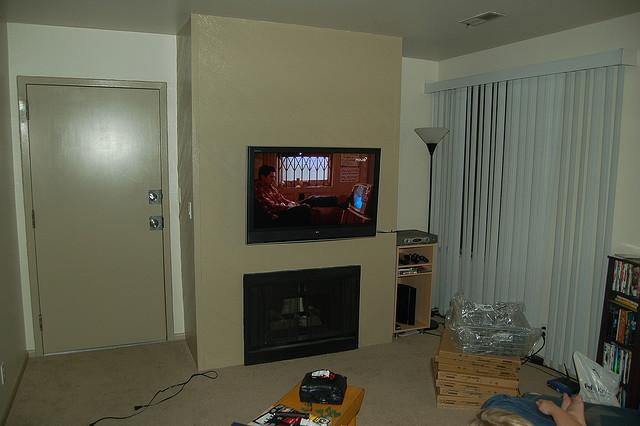What is displayed on the TV screen?
Short answer required. Show. What material is the floor made of?
Answer briefly. Carpet. How many pieces of technology are in the picture?
Quick response, please. 3. How many squares are on the carpet?
Answer briefly. 1. Is this room filled with lots of furniture?
Be succinct. No. Which room is this?
Be succinct. Living room. Is the TV mounted or on a stand?
Write a very short answer. Mounted. What room is this?
Short answer required. Living room. What is on the TV?
Be succinct. Movie. Where is the pink light eliminating from?
Write a very short answer. Tv. Is it sunny outside?
Concise answer only. No. What is on the floor next to the wall with the windows?
Keep it brief. Boxes. What kind of blinds cover the window?
Give a very brief answer. Vertical. Does the door handle turn?
Give a very brief answer. Yes. Is there a calendar on the wall?
Keep it brief. No. What is inside the box?
Answer briefly. Pizza. Is James Dean in the room?
Write a very short answer. No. Is that a flat screen TV?
Concise answer only. Yes. Is the tv on?
Short answer required. Yes. Does this room appear clean?
Quick response, please. No. What is above the mantle?
Write a very short answer. Tv. Are they in the living room?
Answer briefly. Yes. Can you see a bike in the picture?
Concise answer only. No. Is the door open?
Keep it brief. No. Is there a painting on the door?
Write a very short answer. No. What is placed on top of the fireplace?
Answer briefly. Tv. Is the television on?
Quick response, please. Yes. Where is the lamp?
Write a very short answer. Corner. Is the door closed?
Keep it brief. Yes. Is the TV plugged in?
Give a very brief answer. Yes. What room of the house is this?
Write a very short answer. Living room. Is there any window in this room?
Give a very brief answer. Yes. What is hanging on the door?
Short answer required. Nothing. Is the TV on or off?
Quick response, please. On. What color is the wall?
Write a very short answer. Tan. What kind of design is on the floor?
Be succinct. Plain. Is this room neat and well organized?
Give a very brief answer. No. Are there posters on the wall?
Give a very brief answer. No. How many things are plugged into the outlets?
Answer briefly. 2. What color is the Xbox?
Give a very brief answer. Black. Where is the TV?
Quick response, please. On wall. Which human gender does this room most likely belong to?
Short answer required. Male. Is the TV on?
Be succinct. Yes. What color is the lamp?
Short answer required. Black. Are there any photos?
Answer briefly. No. What type of floor is in this room?
Keep it brief. Carpet. What yellow thing is in front of the TV?
Answer briefly. Table. Are there any people in the room?
Give a very brief answer. Yes. Does the lamp in the corner of the room appear to be on?
Quick response, please. No. 